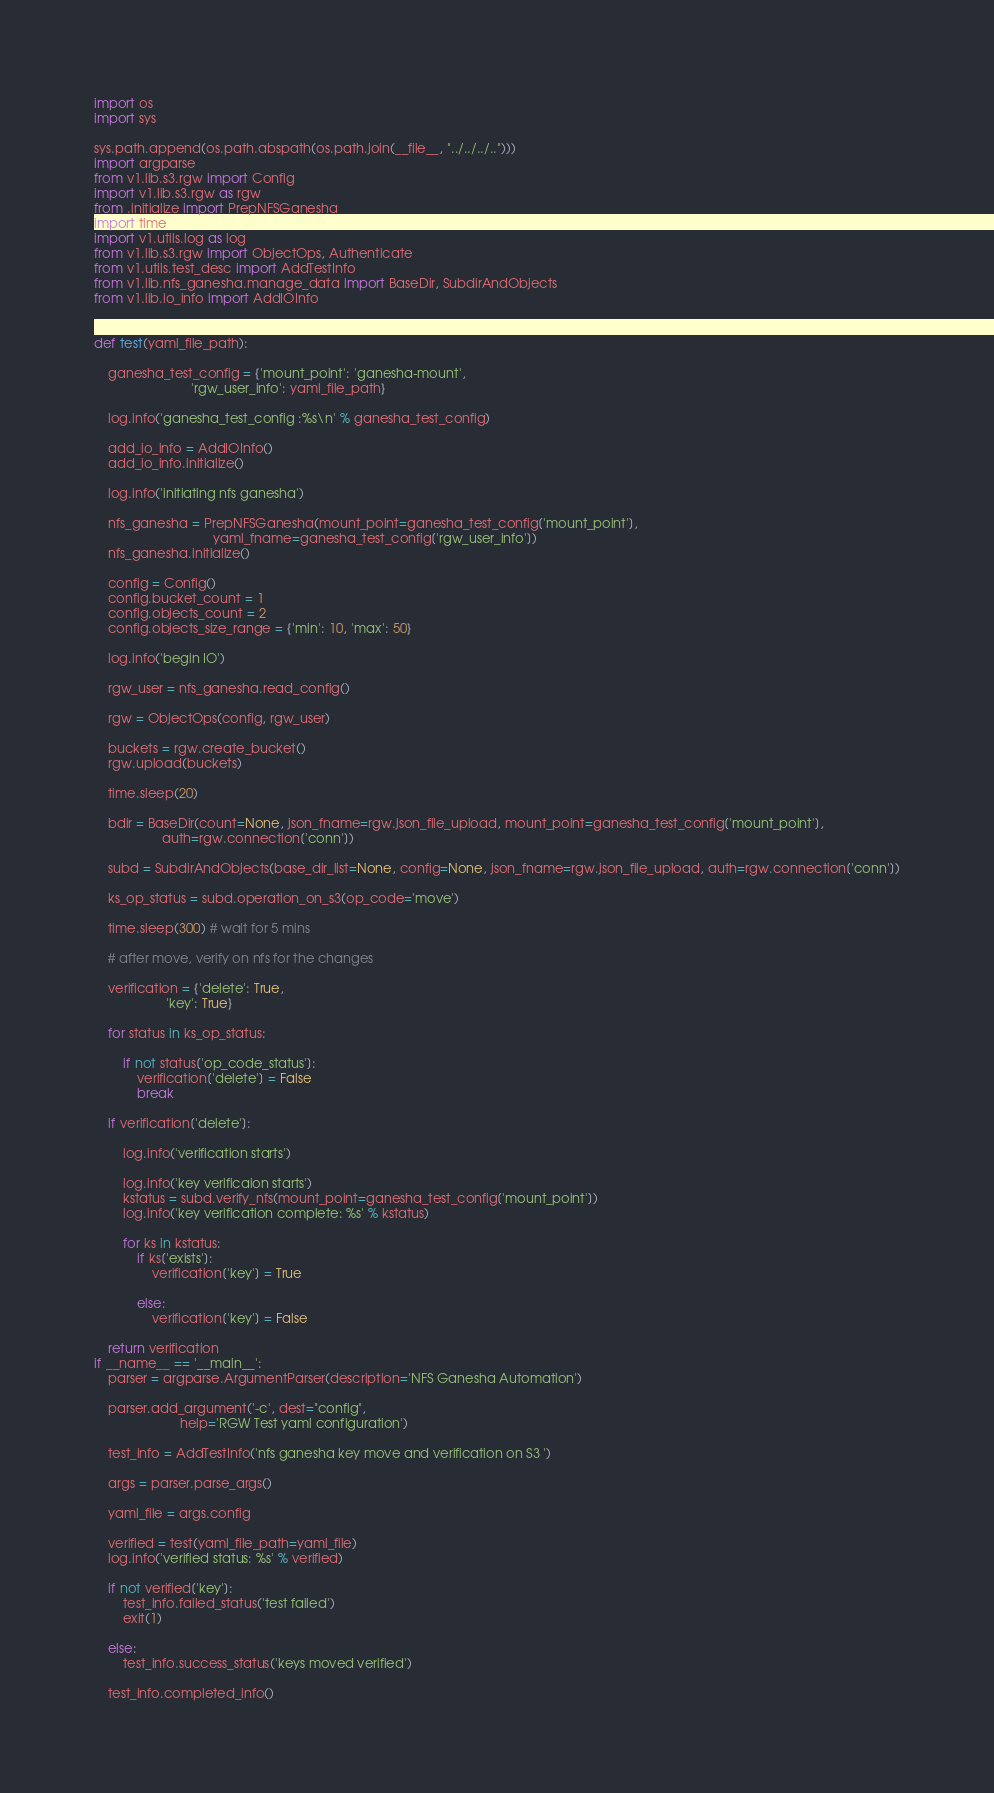<code> <loc_0><loc_0><loc_500><loc_500><_Python_>import os
import sys

sys.path.append(os.path.abspath(os.path.join(__file__, "../../../..")))
import argparse
from v1.lib.s3.rgw import Config
import v1.lib.s3.rgw as rgw
from .initialize import PrepNFSGanesha
import time
import v1.utils.log as log
from v1.lib.s3.rgw import ObjectOps, Authenticate
from v1.utils.test_desc import AddTestInfo
from v1.lib.nfs_ganesha.manage_data import BaseDir, SubdirAndObjects
from v1.lib.io_info import AddIOInfo


def test(yaml_file_path):

    ganesha_test_config = {'mount_point': 'ganesha-mount',
                           'rgw_user_info': yaml_file_path}

    log.info('ganesha_test_config :%s\n' % ganesha_test_config)

    add_io_info = AddIOInfo()
    add_io_info.initialize()

    log.info('initiating nfs ganesha')

    nfs_ganesha = PrepNFSGanesha(mount_point=ganesha_test_config['mount_point'],
                                 yaml_fname=ganesha_test_config['rgw_user_info'])
    nfs_ganesha.initialize()

    config = Config()
    config.bucket_count = 1
    config.objects_count = 2
    config.objects_size_range = {'min': 10, 'max': 50}

    log.info('begin IO')

    rgw_user = nfs_ganesha.read_config()

    rgw = ObjectOps(config, rgw_user)

    buckets = rgw.create_bucket()
    rgw.upload(buckets)

    time.sleep(20)

    bdir = BaseDir(count=None, json_fname=rgw.json_file_upload, mount_point=ganesha_test_config['mount_point'],
                   auth=rgw.connection['conn'])

    subd = SubdirAndObjects(base_dir_list=None, config=None, json_fname=rgw.json_file_upload, auth=rgw.connection['conn'])

    ks_op_status = subd.operation_on_s3(op_code='move')

    time.sleep(300) # wait for 5 mins

    # after move, verify on nfs for the changes

    verification = {'delete': True,
                    'key': True}

    for status in ks_op_status:

        if not status['op_code_status']:
            verification['delete'] = False
            break

    if verification['delete']:

        log.info('verification starts')

        log.info('key verificaion starts')
        kstatus = subd.verify_nfs(mount_point=ganesha_test_config['mount_point'])
        log.info('key verification complete: %s' % kstatus)

        for ks in kstatus:
            if ks['exists']:
                verification['key'] = True

            else:
                verification['key'] = False

    return verification
if __name__ == '__main__':
    parser = argparse.ArgumentParser(description='NFS Ganesha Automation')

    parser.add_argument('-c', dest="config",
                        help='RGW Test yaml configuration')

    test_info = AddTestInfo('nfs ganesha key move and verification on S3 ')

    args = parser.parse_args()

    yaml_file = args.config

    verified = test(yaml_file_path=yaml_file)
    log.info('verified status: %s' % verified)

    if not verified['key']:
        test_info.failed_status('test failed')
        exit(1)

    else:
        test_info.success_status('keys moved verified')

    test_info.completed_info()</code> 